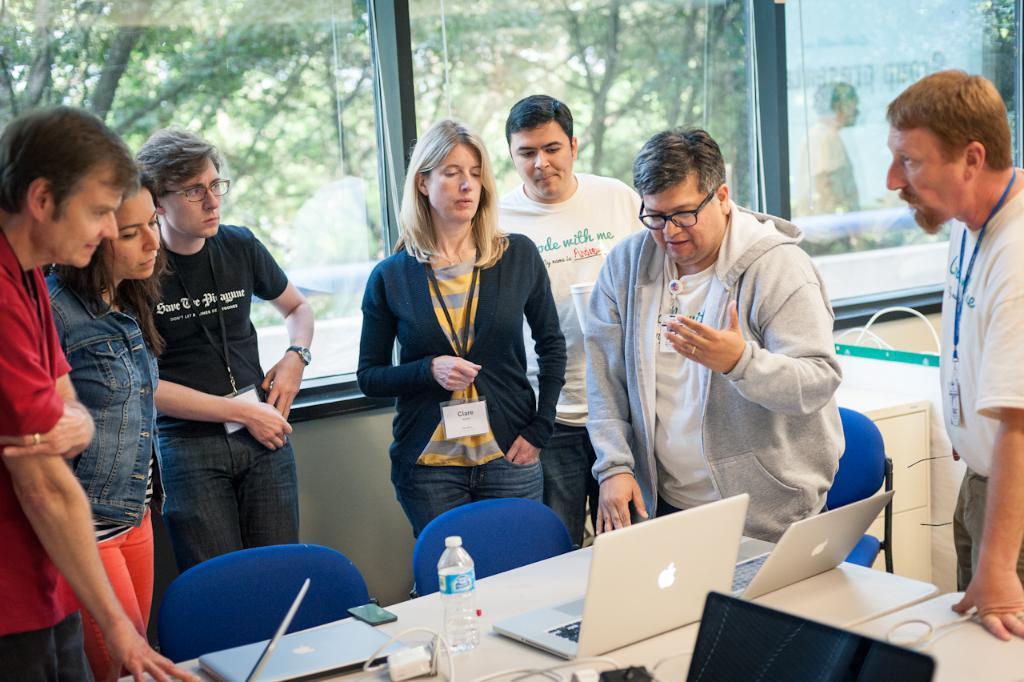Describe this image in one or two sentences. This picture is of inside. In the foreground we can see a group of people standing and there is a table on the top of which a bottle, a mobile phone and laptops are placed. In the center there is a man wearing white color t-shirt, standing and seems to be talking. In the background we can see a window and through that we can see the trees. 